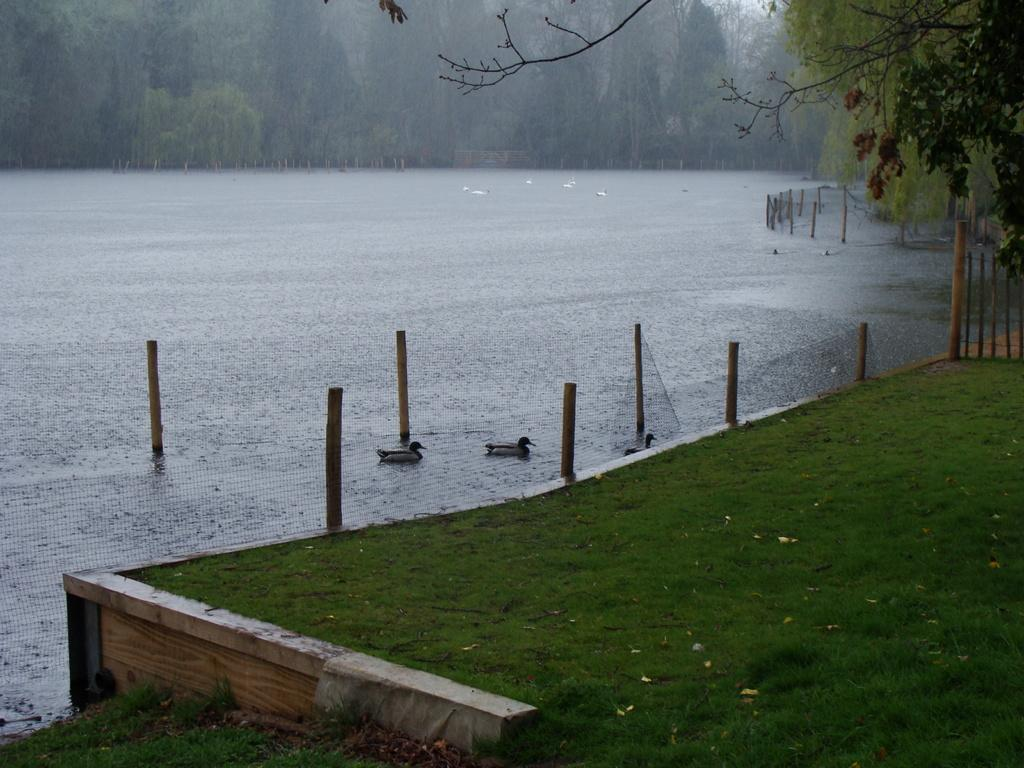What type of animals can be seen on the water in the image? There are swans on the water in the image. What other creatures are present in the image? There are birds in the image. What can be seen in the background of the image? There are trees and poles in the background of the image. What type of surface is visible in the image? There is ground visible in the image. What type of cherry is being used as a fork in the image? There is no cherry or fork present in the image. What card game is being played in the image? There is no card game or cards present in the image. 